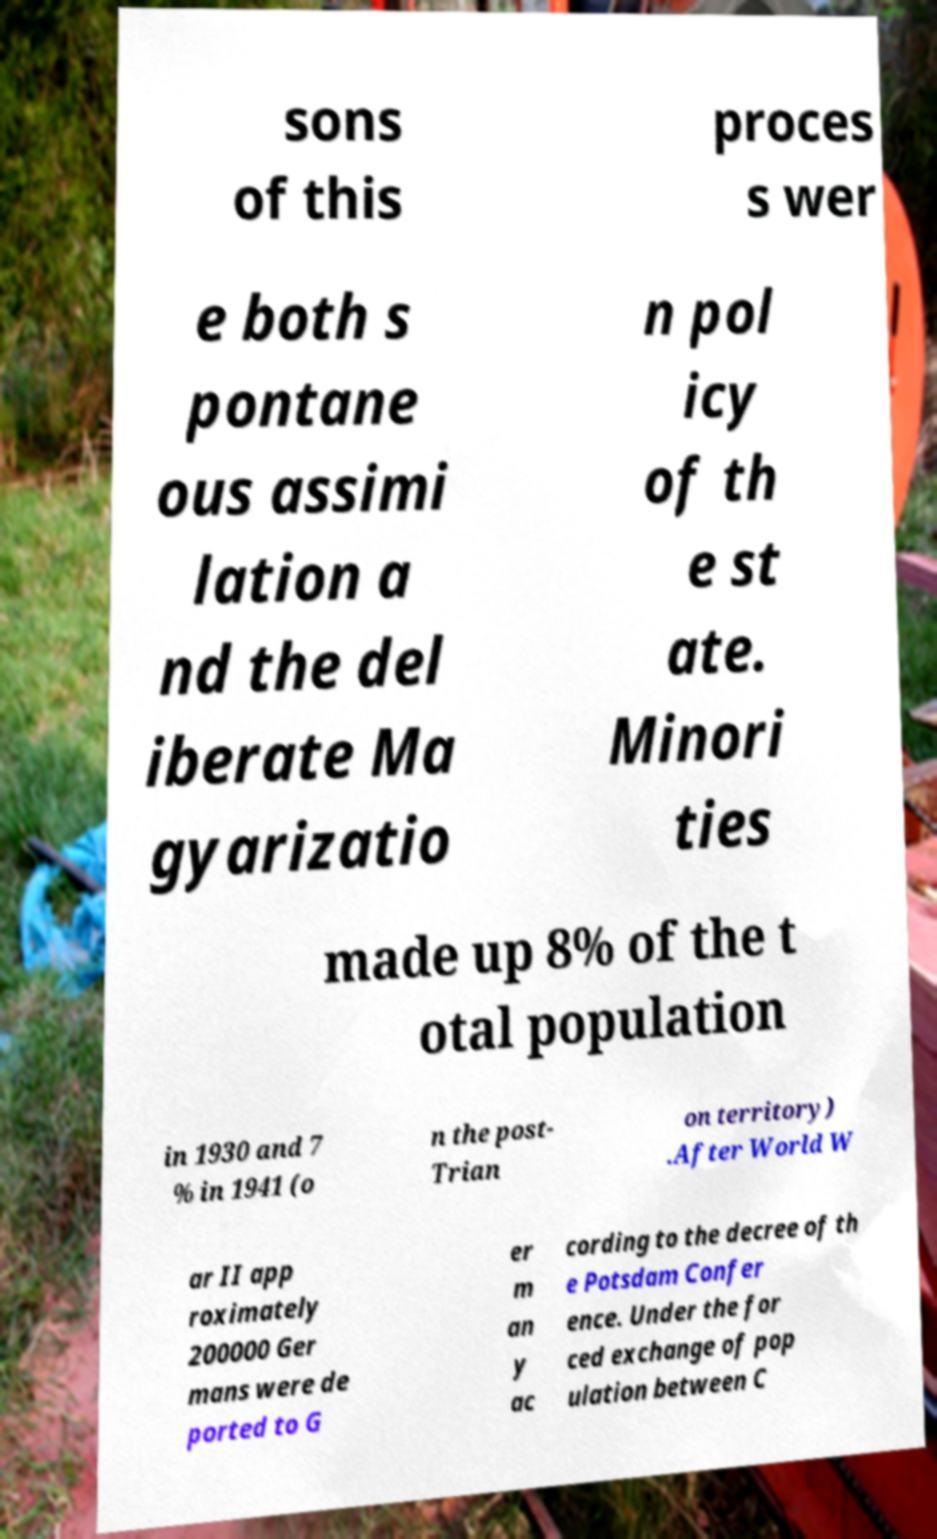I need the written content from this picture converted into text. Can you do that? sons of this proces s wer e both s pontane ous assimi lation a nd the del iberate Ma gyarizatio n pol icy of th e st ate. Minori ties made up 8% of the t otal population in 1930 and 7 % in 1941 (o n the post- Trian on territory) .After World W ar II app roximately 200000 Ger mans were de ported to G er m an y ac cording to the decree of th e Potsdam Confer ence. Under the for ced exchange of pop ulation between C 